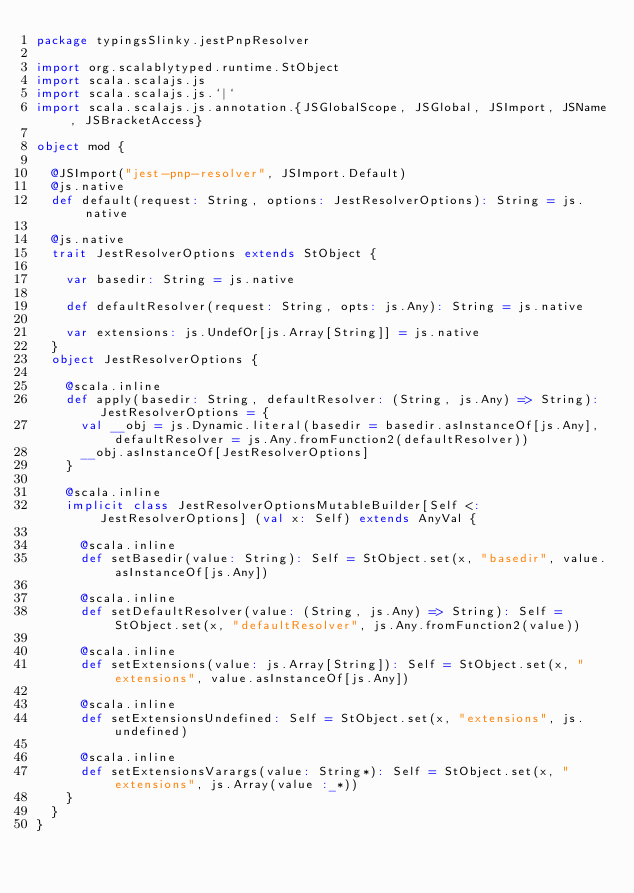<code> <loc_0><loc_0><loc_500><loc_500><_Scala_>package typingsSlinky.jestPnpResolver

import org.scalablytyped.runtime.StObject
import scala.scalajs.js
import scala.scalajs.js.`|`
import scala.scalajs.js.annotation.{JSGlobalScope, JSGlobal, JSImport, JSName, JSBracketAccess}

object mod {
  
  @JSImport("jest-pnp-resolver", JSImport.Default)
  @js.native
  def default(request: String, options: JestResolverOptions): String = js.native
  
  @js.native
  trait JestResolverOptions extends StObject {
    
    var basedir: String = js.native
    
    def defaultResolver(request: String, opts: js.Any): String = js.native
    
    var extensions: js.UndefOr[js.Array[String]] = js.native
  }
  object JestResolverOptions {
    
    @scala.inline
    def apply(basedir: String, defaultResolver: (String, js.Any) => String): JestResolverOptions = {
      val __obj = js.Dynamic.literal(basedir = basedir.asInstanceOf[js.Any], defaultResolver = js.Any.fromFunction2(defaultResolver))
      __obj.asInstanceOf[JestResolverOptions]
    }
    
    @scala.inline
    implicit class JestResolverOptionsMutableBuilder[Self <: JestResolverOptions] (val x: Self) extends AnyVal {
      
      @scala.inline
      def setBasedir(value: String): Self = StObject.set(x, "basedir", value.asInstanceOf[js.Any])
      
      @scala.inline
      def setDefaultResolver(value: (String, js.Any) => String): Self = StObject.set(x, "defaultResolver", js.Any.fromFunction2(value))
      
      @scala.inline
      def setExtensions(value: js.Array[String]): Self = StObject.set(x, "extensions", value.asInstanceOf[js.Any])
      
      @scala.inline
      def setExtensionsUndefined: Self = StObject.set(x, "extensions", js.undefined)
      
      @scala.inline
      def setExtensionsVarargs(value: String*): Self = StObject.set(x, "extensions", js.Array(value :_*))
    }
  }
}
</code> 